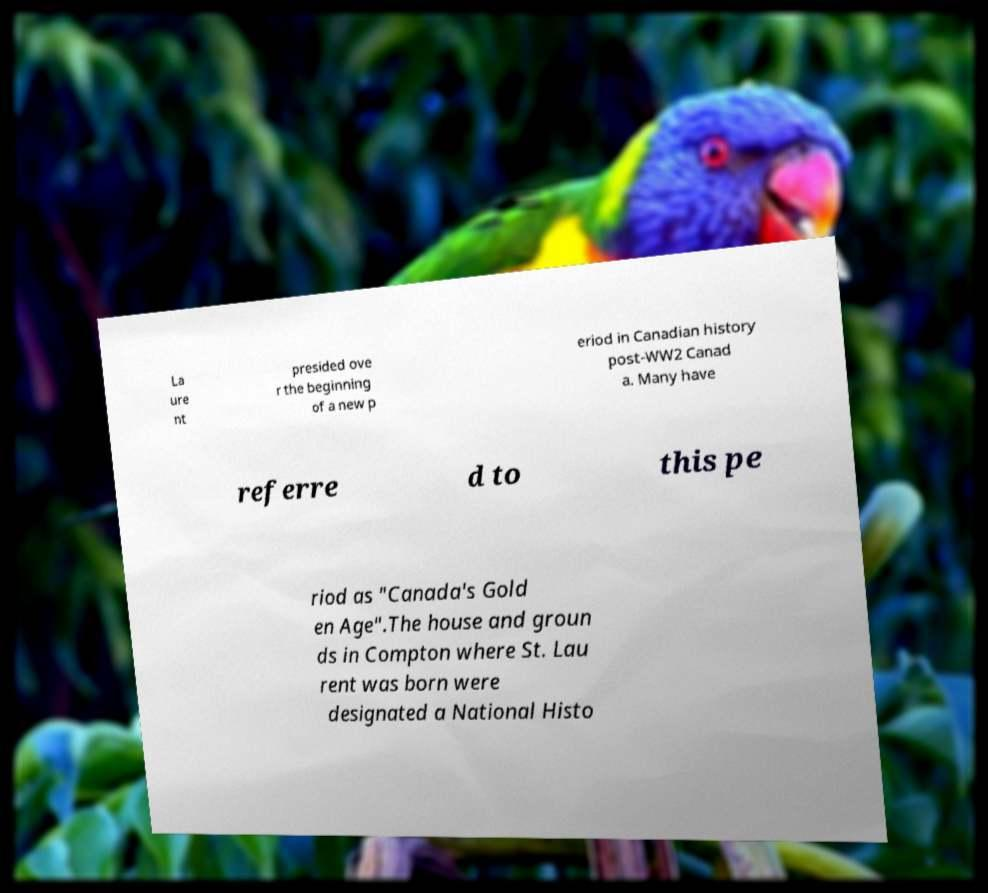Could you extract and type out the text from this image? La ure nt presided ove r the beginning of a new p eriod in Canadian history post-WW2 Canad a. Many have referre d to this pe riod as "Canada's Gold en Age".The house and groun ds in Compton where St. Lau rent was born were designated a National Histo 